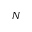<formula> <loc_0><loc_0><loc_500><loc_500>N</formula> 